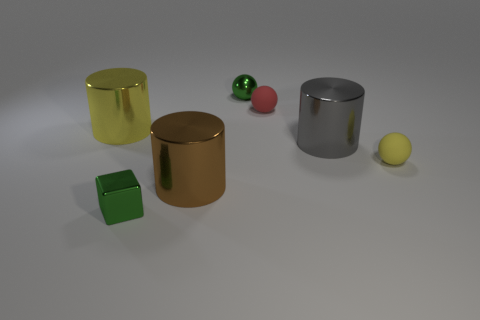What number of things are rubber things to the left of the gray metal cylinder or tiny metal objects in front of the red rubber sphere?
Offer a very short reply. 2. There is a yellow object that is to the right of the brown cylinder; is its size the same as the tiny red thing?
Provide a succinct answer. Yes. What color is the tiny rubber sphere that is on the left side of the tiny yellow matte object?
Ensure brevity in your answer.  Red. There is a tiny shiny thing that is the same shape as the tiny red rubber thing; what color is it?
Ensure brevity in your answer.  Green. There is a yellow object that is to the left of the large metal object right of the red thing; what number of tiny shiny cubes are in front of it?
Your response must be concise. 1. Is there anything else that is made of the same material as the big yellow cylinder?
Your answer should be compact. Yes. Is the number of tiny red matte spheres that are to the left of the large gray cylinder less than the number of red objects?
Offer a very short reply. No. Is the small block the same color as the tiny metal ball?
Your answer should be compact. Yes. What size is the other metal object that is the same shape as the small yellow object?
Keep it short and to the point. Small. How many small green balls have the same material as the big gray object?
Offer a very short reply. 1. 